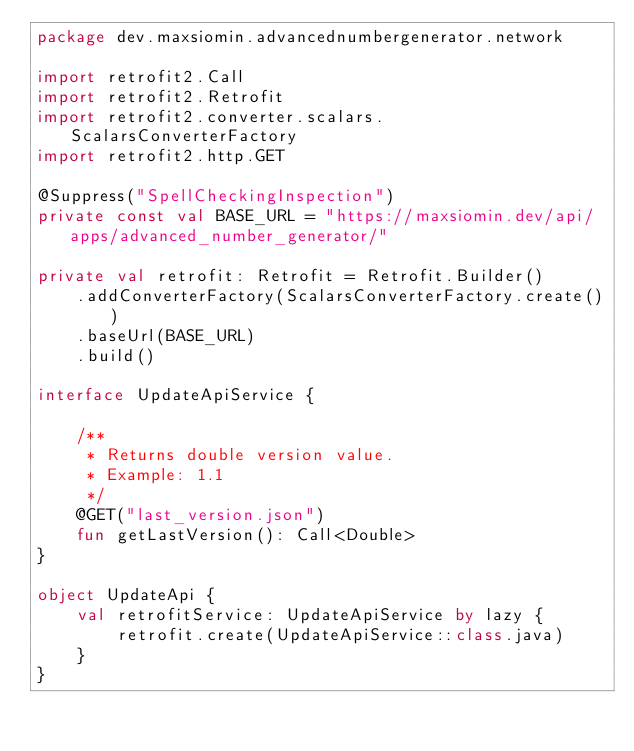Convert code to text. <code><loc_0><loc_0><loc_500><loc_500><_Kotlin_>package dev.maxsiomin.advancednumbergenerator.network

import retrofit2.Call
import retrofit2.Retrofit
import retrofit2.converter.scalars.ScalarsConverterFactory
import retrofit2.http.GET

@Suppress("SpellCheckingInspection")
private const val BASE_URL = "https://maxsiomin.dev/api/apps/advanced_number_generator/"

private val retrofit: Retrofit = Retrofit.Builder()
    .addConverterFactory(ScalarsConverterFactory.create())
    .baseUrl(BASE_URL)
    .build()

interface UpdateApiService {

    /**
     * Returns double version value.
     * Example: 1.1
     */
    @GET("last_version.json")
    fun getLastVersion(): Call<Double>
}

object UpdateApi {
    val retrofitService: UpdateApiService by lazy {
        retrofit.create(UpdateApiService::class.java)
    }
}
</code> 